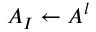Convert formula to latex. <formula><loc_0><loc_0><loc_500><loc_500>A _ { I } \leftarrow A ^ { l }</formula> 